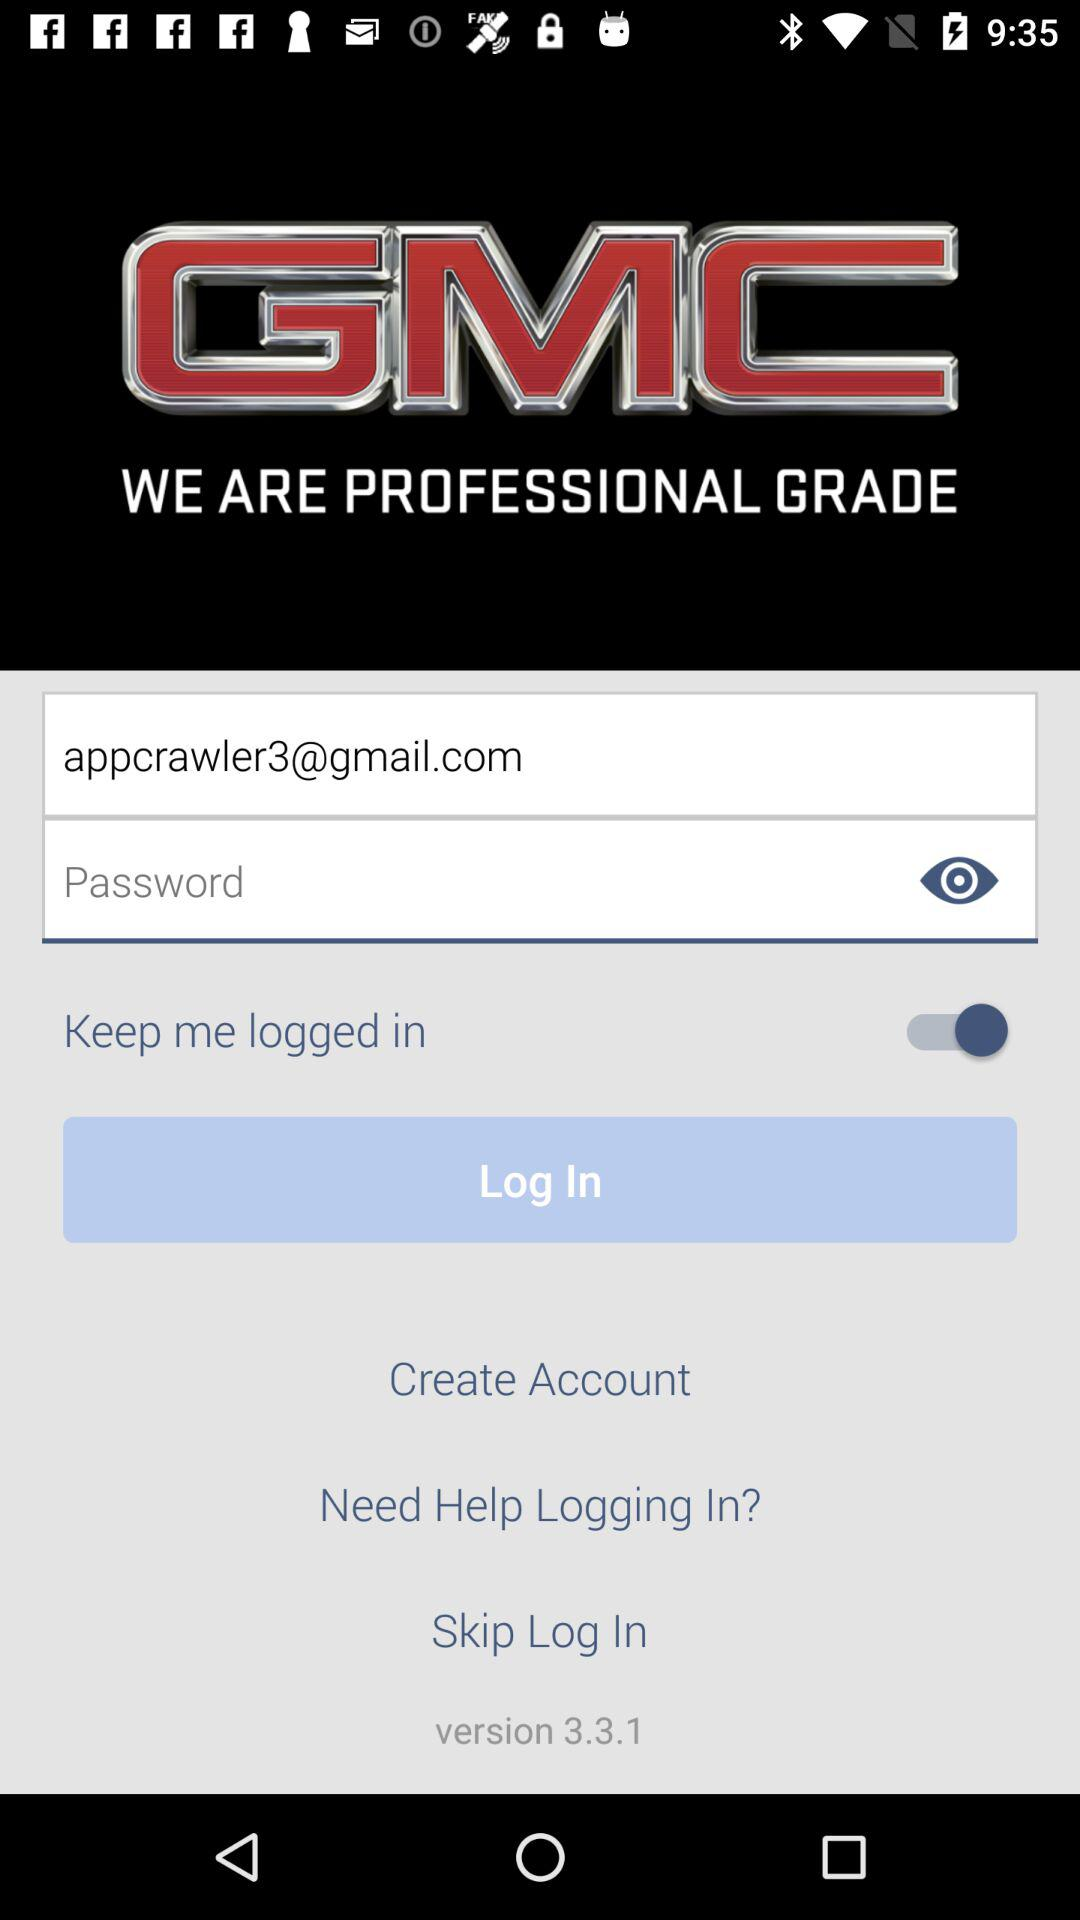What is the email address of the user? The email address is appcrawler3@gmail.com. 